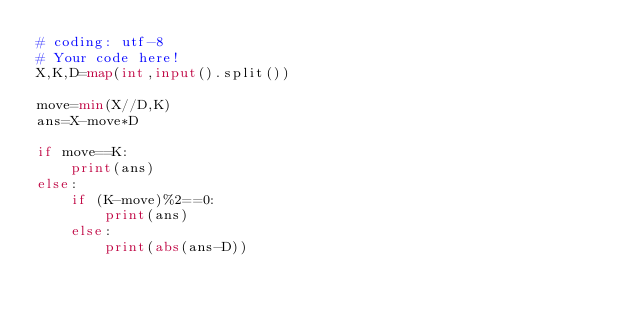<code> <loc_0><loc_0><loc_500><loc_500><_Python_># coding: utf-8
# Your code here!
X,K,D=map(int,input().split())

move=min(X//D,K)
ans=X-move*D

if move==K:
    print(ans)
else:
    if (K-move)%2==0:
        print(ans)
    else:
        print(abs(ans-D))</code> 